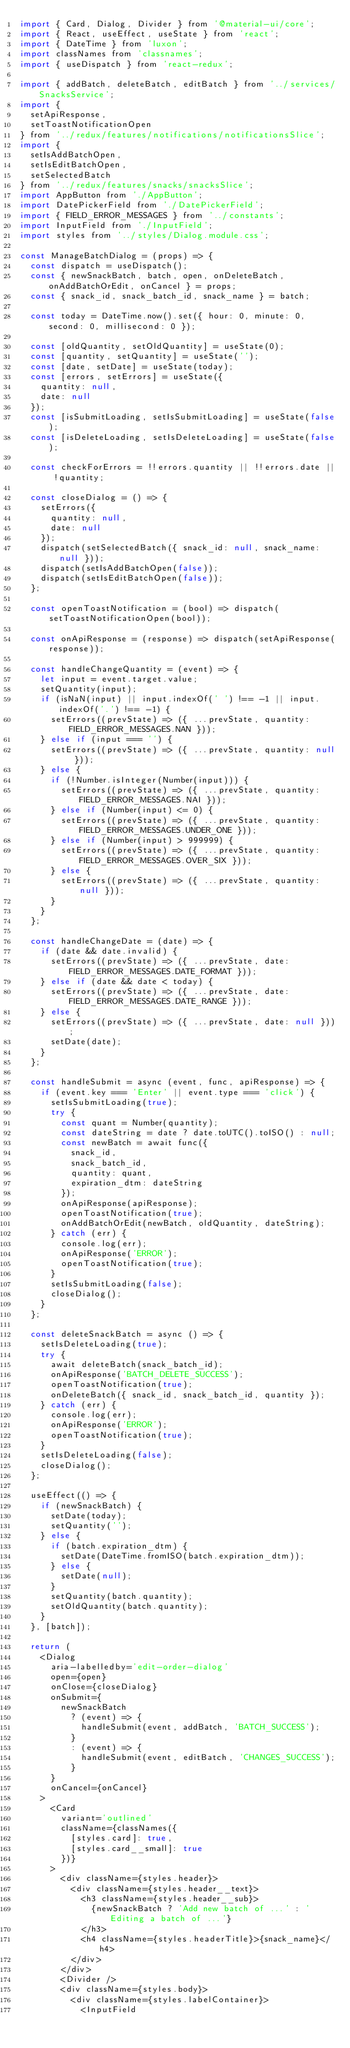<code> <loc_0><loc_0><loc_500><loc_500><_JavaScript_>import { Card, Dialog, Divider } from '@material-ui/core';
import { React, useEffect, useState } from 'react';
import { DateTime } from 'luxon';
import classNames from 'classnames';
import { useDispatch } from 'react-redux';

import { addBatch, deleteBatch, editBatch } from '../services/SnacksService';
import {
  setApiResponse,
  setToastNotificationOpen
} from '../redux/features/notifications/notificationsSlice';
import {
  setIsAddBatchOpen,
  setIsEditBatchOpen,
  setSelectedBatch
} from '../redux/features/snacks/snacksSlice';
import AppButton from './AppButton';
import DatePickerField from './DatePickerField';
import { FIELD_ERROR_MESSAGES } from '../constants';
import InputField from './InputField';
import styles from '../styles/Dialog.module.css';

const ManageBatchDialog = (props) => {
  const dispatch = useDispatch();
  const { newSnackBatch, batch, open, onDeleteBatch, onAddBatchOrEdit, onCancel } = props;
  const { snack_id, snack_batch_id, snack_name } = batch;

  const today = DateTime.now().set({ hour: 0, minute: 0, second: 0, millisecond: 0 });

  const [oldQuantity, setOldQuantity] = useState(0);
  const [quantity, setQuantity] = useState('');
  const [date, setDate] = useState(today);
  const [errors, setErrors] = useState({
    quantity: null,
    date: null
  });
  const [isSubmitLoading, setIsSubmitLoading] = useState(false);
  const [isDeleteLoading, setIsDeleteLoading] = useState(false);

  const checkForErrors = !!errors.quantity || !!errors.date || !quantity;

  const closeDialog = () => {
    setErrors({
      quantity: null,
      date: null
    });
    dispatch(setSelectedBatch({ snack_id: null, snack_name: null }));
    dispatch(setIsAddBatchOpen(false));
    dispatch(setIsEditBatchOpen(false));
  };

  const openToastNotification = (bool) => dispatch(setToastNotificationOpen(bool));

  const onApiResponse = (response) => dispatch(setApiResponse(response));

  const handleChangeQuantity = (event) => {
    let input = event.target.value;
    setQuantity(input);
    if (isNaN(input) || input.indexOf(' ') !== -1 || input.indexOf('.') !== -1) {
      setErrors((prevState) => ({ ...prevState, quantity: FIELD_ERROR_MESSAGES.NAN }));
    } else if (input === '') {
      setErrors((prevState) => ({ ...prevState, quantity: null }));
    } else {
      if (!Number.isInteger(Number(input))) {
        setErrors((prevState) => ({ ...prevState, quantity: FIELD_ERROR_MESSAGES.NAI }));
      } else if (Number(input) <= 0) {
        setErrors((prevState) => ({ ...prevState, quantity: FIELD_ERROR_MESSAGES.UNDER_ONE }));
      } else if (Number(input) > 999999) {
        setErrors((prevState) => ({ ...prevState, quantity: FIELD_ERROR_MESSAGES.OVER_SIX }));
      } else {
        setErrors((prevState) => ({ ...prevState, quantity: null }));
      }
    }
  };

  const handleChangeDate = (date) => {
    if (date && date.invalid) {
      setErrors((prevState) => ({ ...prevState, date: FIELD_ERROR_MESSAGES.DATE_FORMAT }));
    } else if (date && date < today) {
      setErrors((prevState) => ({ ...prevState, date: FIELD_ERROR_MESSAGES.DATE_RANGE }));
    } else {
      setErrors((prevState) => ({ ...prevState, date: null }));
      setDate(date);
    }
  };

  const handleSubmit = async (event, func, apiResponse) => {
    if (event.key === 'Enter' || event.type === 'click') {
      setIsSubmitLoading(true);
      try {
        const quant = Number(quantity);
        const dateString = date ? date.toUTC().toISO() : null;
        const newBatch = await func({
          snack_id,
          snack_batch_id,
          quantity: quant,
          expiration_dtm: dateString
        });
        onApiResponse(apiResponse);
        openToastNotification(true);
        onAddBatchOrEdit(newBatch, oldQuantity, dateString);
      } catch (err) {
        console.log(err);
        onApiResponse('ERROR');
        openToastNotification(true);
      }
      setIsSubmitLoading(false);
      closeDialog(); 
    }
  };

  const deleteSnackBatch = async () => {
    setIsDeleteLoading(true);
    try {
      await deleteBatch(snack_batch_id);
      onApiResponse('BATCH_DELETE_SUCCESS');
      openToastNotification(true);
      onDeleteBatch({ snack_id, snack_batch_id, quantity });
    } catch (err) {
      console.log(err);
      onApiResponse('ERROR');
      openToastNotification(true);
    }
    setIsDeleteLoading(false);
    closeDialog();
  };

  useEffect(() => {
    if (newSnackBatch) {
      setDate(today);
      setQuantity('');
    } else {
      if (batch.expiration_dtm) {
        setDate(DateTime.fromISO(batch.expiration_dtm));
      } else {
        setDate(null);
      }
      setQuantity(batch.quantity);
      setOldQuantity(batch.quantity);
    }
  }, [batch]);

  return (
    <Dialog
      aria-labelledby='edit-order-dialog'
      open={open}
      onClose={closeDialog}
      onSubmit={
        newSnackBatch
          ? (event) => {
            handleSubmit(event, addBatch, 'BATCH_SUCCESS');
          }
          : (event) => {
            handleSubmit(event, editBatch, 'CHANGES_SUCCESS');
          }
      }
      onCancel={onCancel}
    >
      <Card
        variant='outlined'
        className={classNames({
          [styles.card]: true,
          [styles.card__small]: true
        })}
      >
        <div className={styles.header}>
          <div className={styles.header__text}>
            <h3 className={styles.header__sub}>
              {newSnackBatch ? 'Add new batch of ...' : 'Editing a batch of ...'}
            </h3>
            <h4 className={styles.headerTitle}>{snack_name}</h4>
          </div>
        </div>
        <Divider />
        <div className={styles.body}>
          <div className={styles.labelContainer}>
            <InputField</code> 